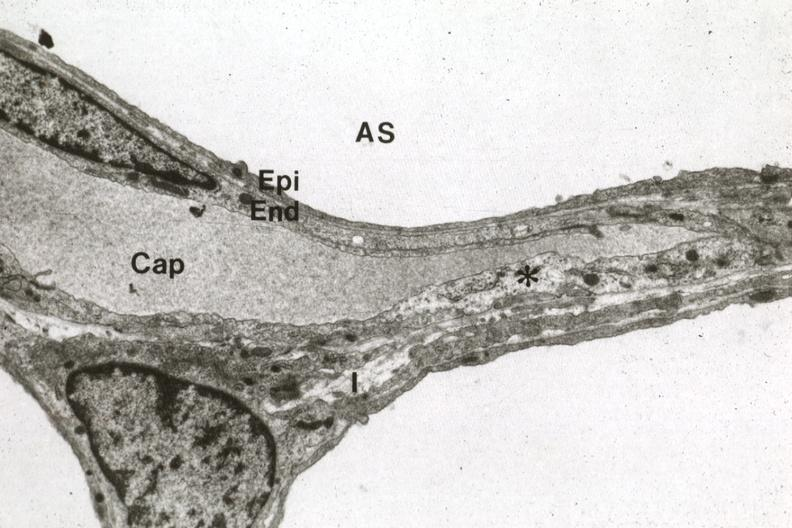what does this image show?
Answer the question using a single word or phrase. Alveolus capillary and interstitial space 